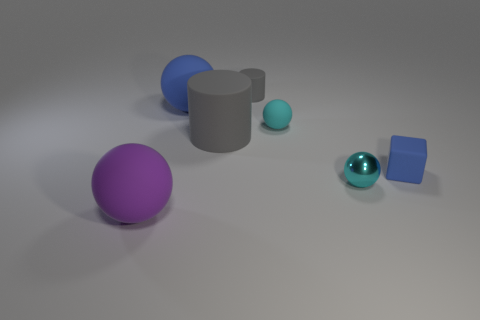Subtract 1 balls. How many balls are left? 3 Subtract all small rubber balls. How many balls are left? 3 Subtract all purple balls. How many balls are left? 3 Subtract all red balls. Subtract all brown cubes. How many balls are left? 4 Add 2 small cyan balls. How many objects exist? 9 Subtract all cylinders. How many objects are left? 5 Subtract all yellow shiny things. Subtract all metal balls. How many objects are left? 6 Add 2 large rubber objects. How many large rubber objects are left? 5 Add 3 brown things. How many brown things exist? 3 Subtract 0 green cubes. How many objects are left? 7 